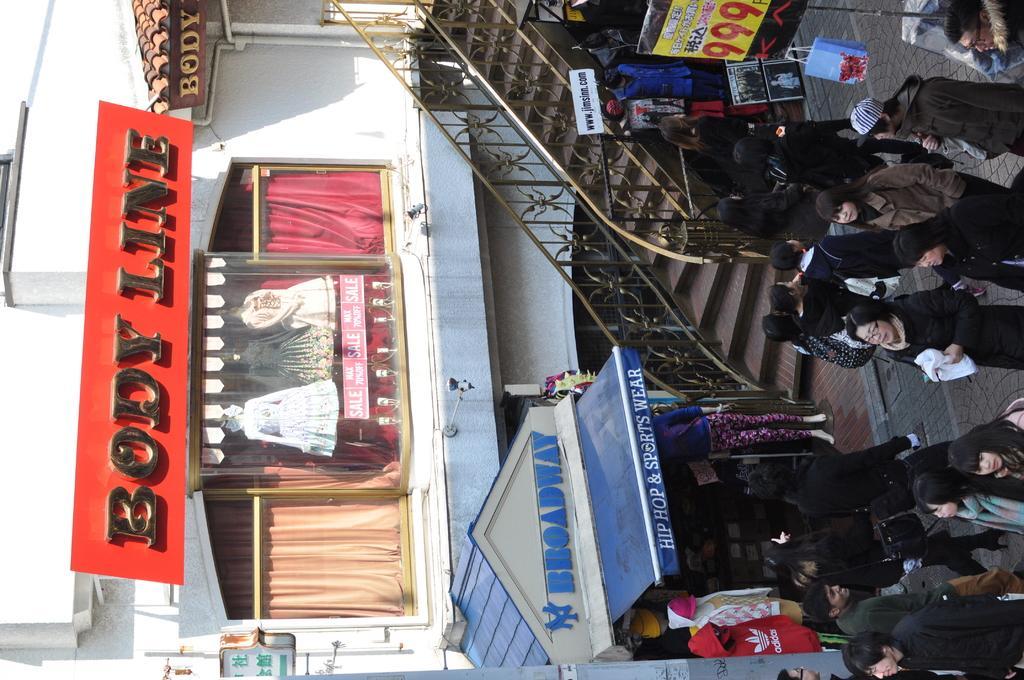Could you give a brief overview of what you see in this image? The picture on a road where people are walking around and in the background we find shops named as BROADWAY , BODY LINE. There are also stairs on the right side of the image. We also find a label of 999 beneath it there are few clothing items. 